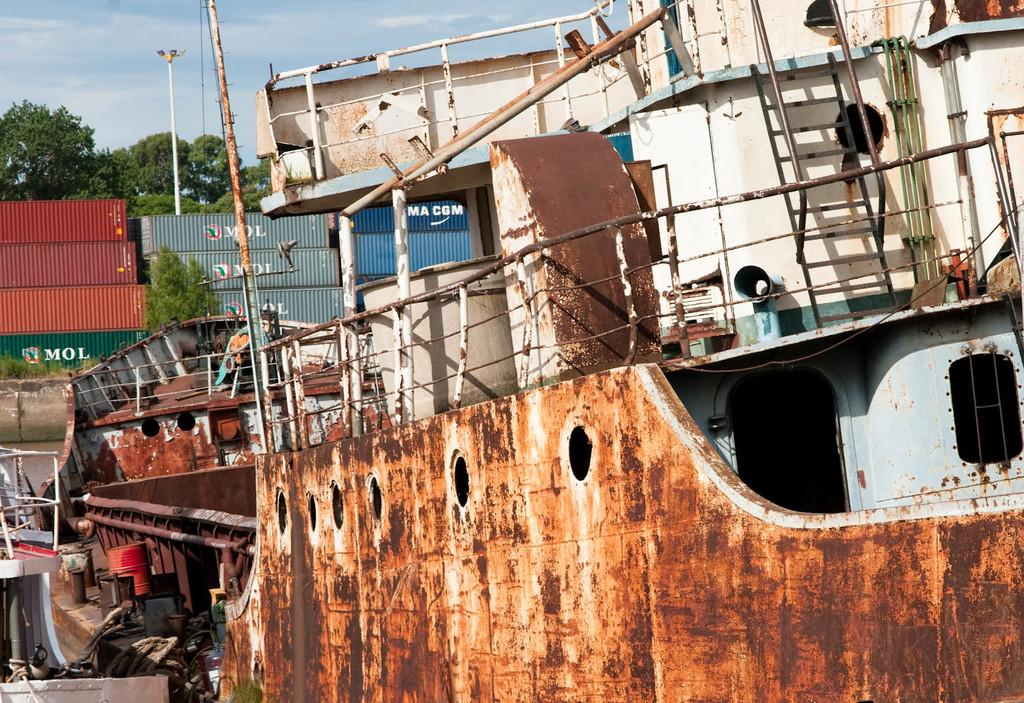<image>
Render a clear and concise summary of the photo. Old ship in front of a green container which says MOL. 